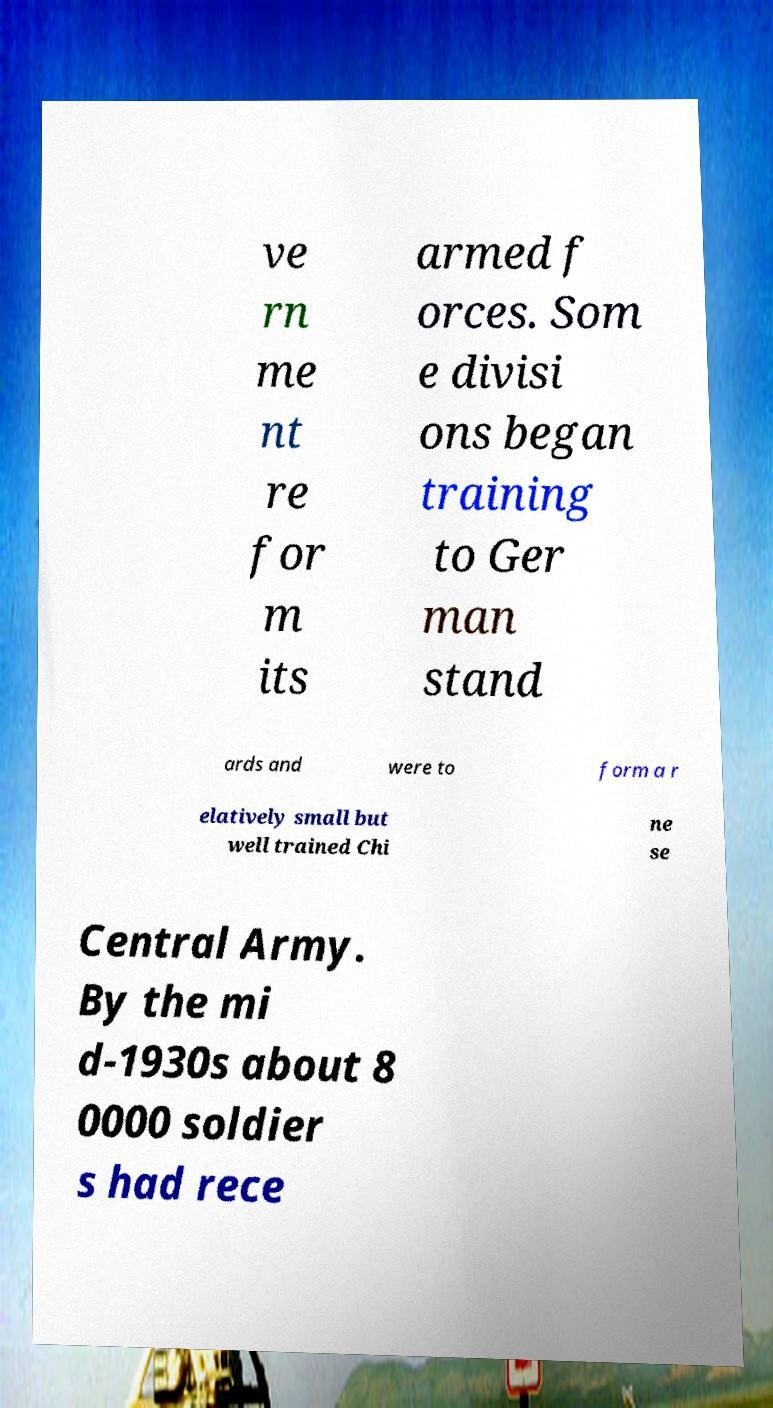Please read and relay the text visible in this image. What does it say? ve rn me nt re for m its armed f orces. Som e divisi ons began training to Ger man stand ards and were to form a r elatively small but well trained Chi ne se Central Army. By the mi d-1930s about 8 0000 soldier s had rece 